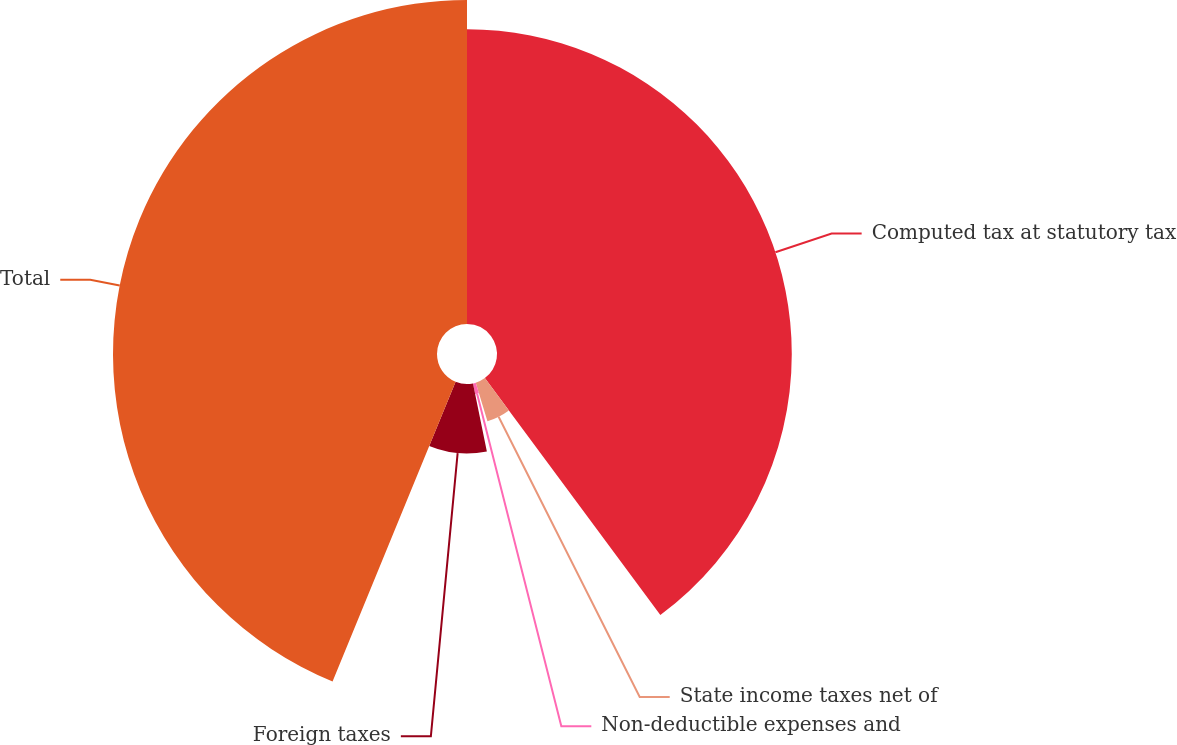Convert chart to OTSL. <chart><loc_0><loc_0><loc_500><loc_500><pie_chart><fcel>Computed tax at statutory tax<fcel>State income taxes net of<fcel>Non-deductible expenses and<fcel>Foreign taxes<fcel>Total<nl><fcel>39.85%<fcel>5.45%<fcel>1.5%<fcel>9.4%<fcel>43.8%<nl></chart> 